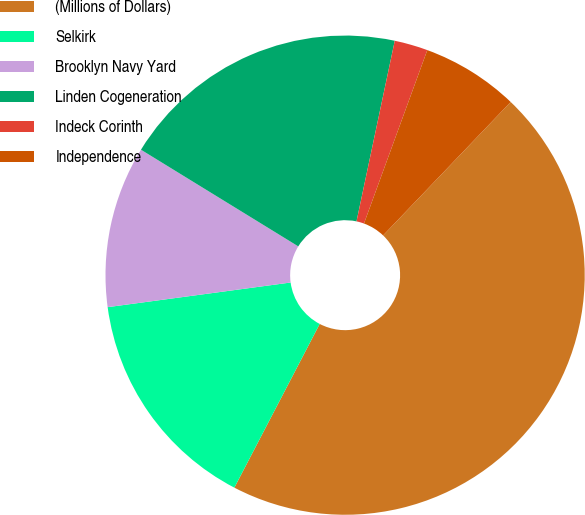Convert chart to OTSL. <chart><loc_0><loc_0><loc_500><loc_500><pie_chart><fcel>(Millions of Dollars)<fcel>Selkirk<fcel>Brooklyn Navy Yard<fcel>Linden Cogeneration<fcel>Indeck Corinth<fcel>Independence<nl><fcel>45.5%<fcel>15.22%<fcel>10.9%<fcel>19.55%<fcel>2.25%<fcel>6.57%<nl></chart> 